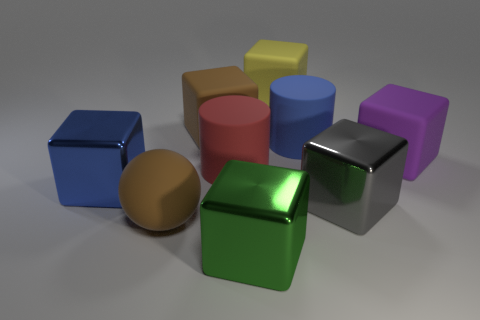How does the lighting in the image affect the appearance of the objects? The lighting in the image creates soft shadows and subtle reflections on the surfaces of the objects, giving them a three-dimensional appearance and highlighting their textures. 